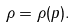Convert formula to latex. <formula><loc_0><loc_0><loc_500><loc_500>\rho = \rho ( p ) .</formula> 